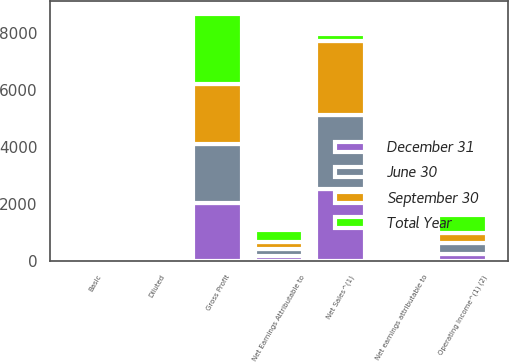Convert chart. <chart><loc_0><loc_0><loc_500><loc_500><stacked_bar_chart><ecel><fcel>Net Sales^(1)<fcel>Gross Profit<fcel>Operating Income^(1) (2)<fcel>Net Earnings Attributable to<fcel>Net earnings attributable to<fcel>Diluted<fcel>Basic<nl><fcel>September 30<fcel>2631<fcel>2094.4<fcel>348<fcel>228.1<fcel>0.6<fcel>0.59<fcel>0.78<nl><fcel>Total Year<fcel>228.1<fcel>2471.4<fcel>632.8<fcel>435.7<fcel>1.15<fcel>1.13<fcel>1.11<nl><fcel>June 30<fcel>2580.5<fcel>2077.6<fcel>397.2<fcel>272.1<fcel>0.72<fcel>0.71<fcel>0.55<nl><fcel>December 31<fcel>2524.4<fcel>2036.4<fcel>228.3<fcel>153<fcel>0.41<fcel>0.4<fcel>0.67<nl></chart> 